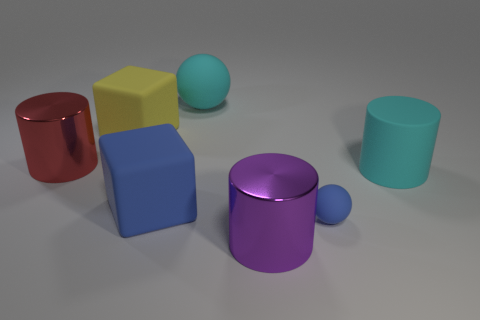There is a ball that is right of the large purple metal cylinder; what size is it?
Give a very brief answer. Small. Is the color of the big matte cylinder the same as the rubber cube in front of the cyan cylinder?
Provide a succinct answer. No. What number of other things are there of the same material as the large cyan cylinder
Make the answer very short. 4. Is the number of tiny gray rubber cubes greater than the number of large balls?
Give a very brief answer. No. Does the big shiny cylinder in front of the tiny ball have the same color as the small matte sphere?
Make the answer very short. No. The tiny matte thing is what color?
Your answer should be very brief. Blue. Is there a big cyan matte thing that is in front of the shiny object behind the big purple metal cylinder?
Your response must be concise. Yes. There is a metallic object in front of the large cyan rubber thing in front of the cyan sphere; what shape is it?
Provide a short and direct response. Cylinder. Are there fewer small cyan blocks than large red cylinders?
Your response must be concise. Yes. Is the big red cylinder made of the same material as the big blue object?
Make the answer very short. No. 